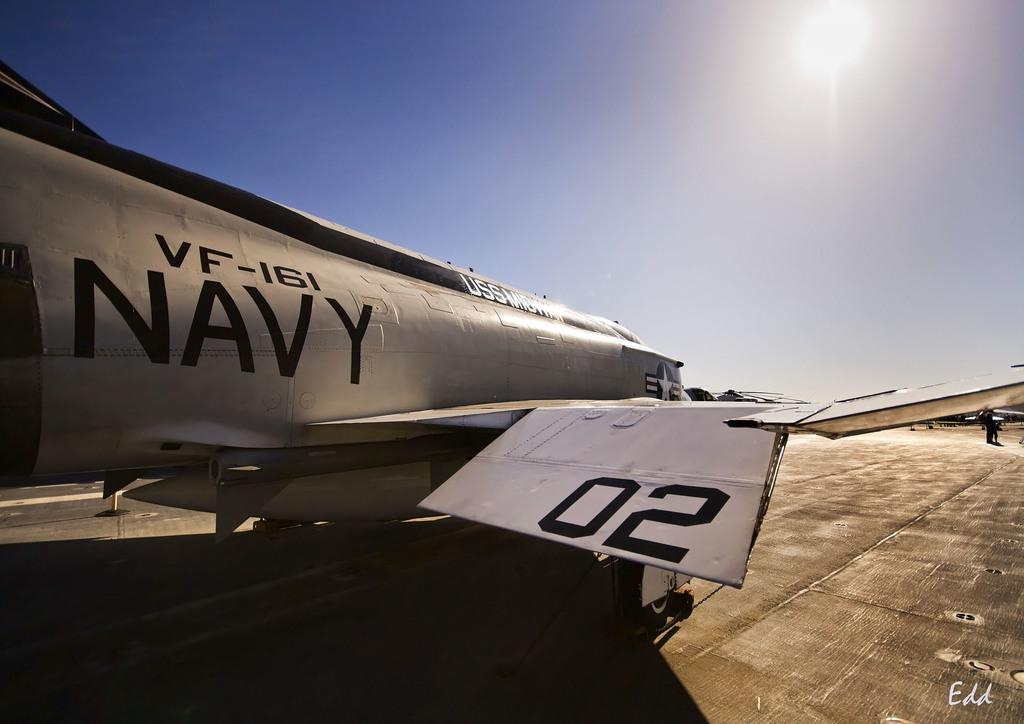<image>
Offer a succinct explanation of the picture presented. a NAVY plane VF-161 is on a sunny runway 